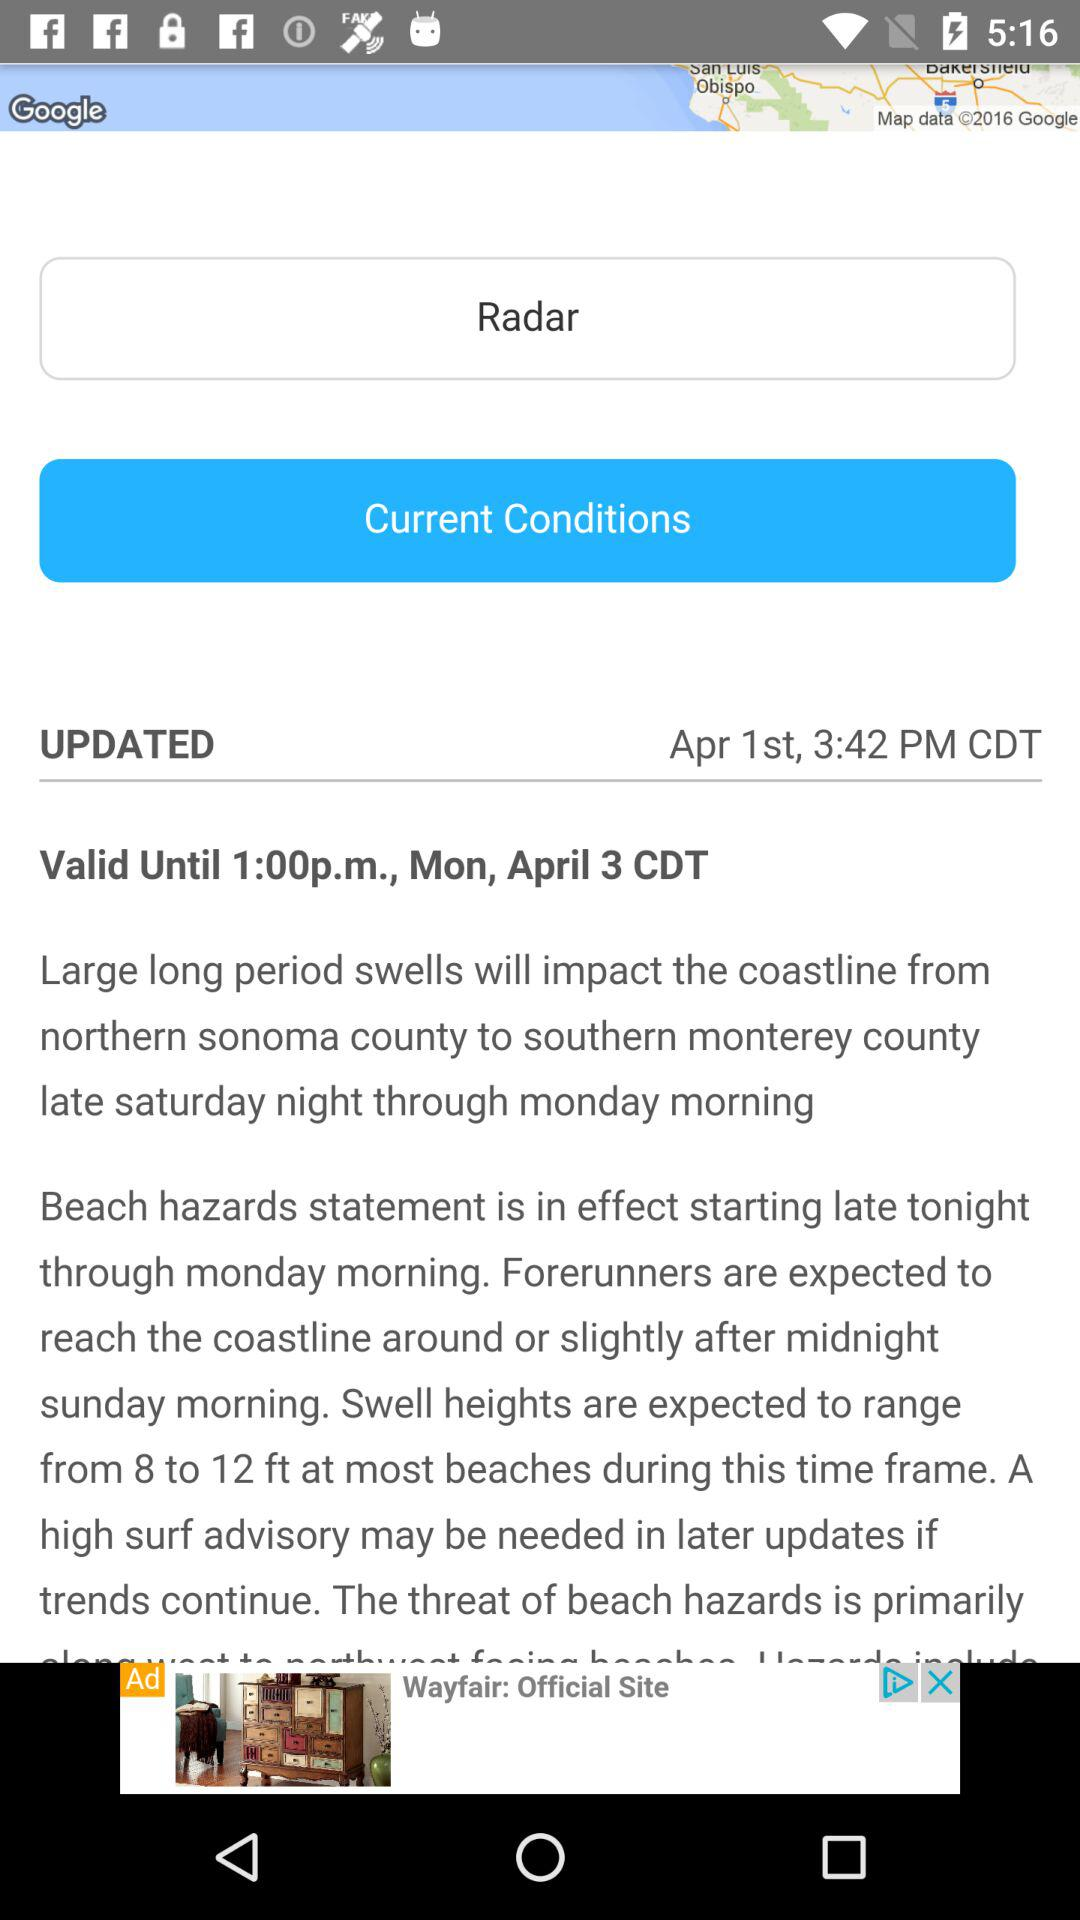What is the validity time displayed? The validity time is 1:00 p.m. 